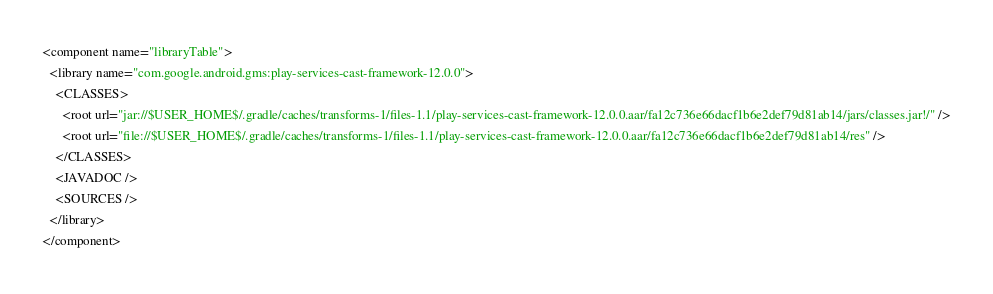Convert code to text. <code><loc_0><loc_0><loc_500><loc_500><_XML_><component name="libraryTable">
  <library name="com.google.android.gms:play-services-cast-framework-12.0.0">
    <CLASSES>
      <root url="jar://$USER_HOME$/.gradle/caches/transforms-1/files-1.1/play-services-cast-framework-12.0.0.aar/fa12c736e66dacf1b6e2def79d81ab14/jars/classes.jar!/" />
      <root url="file://$USER_HOME$/.gradle/caches/transforms-1/files-1.1/play-services-cast-framework-12.0.0.aar/fa12c736e66dacf1b6e2def79d81ab14/res" />
    </CLASSES>
    <JAVADOC />
    <SOURCES />
  </library>
</component></code> 